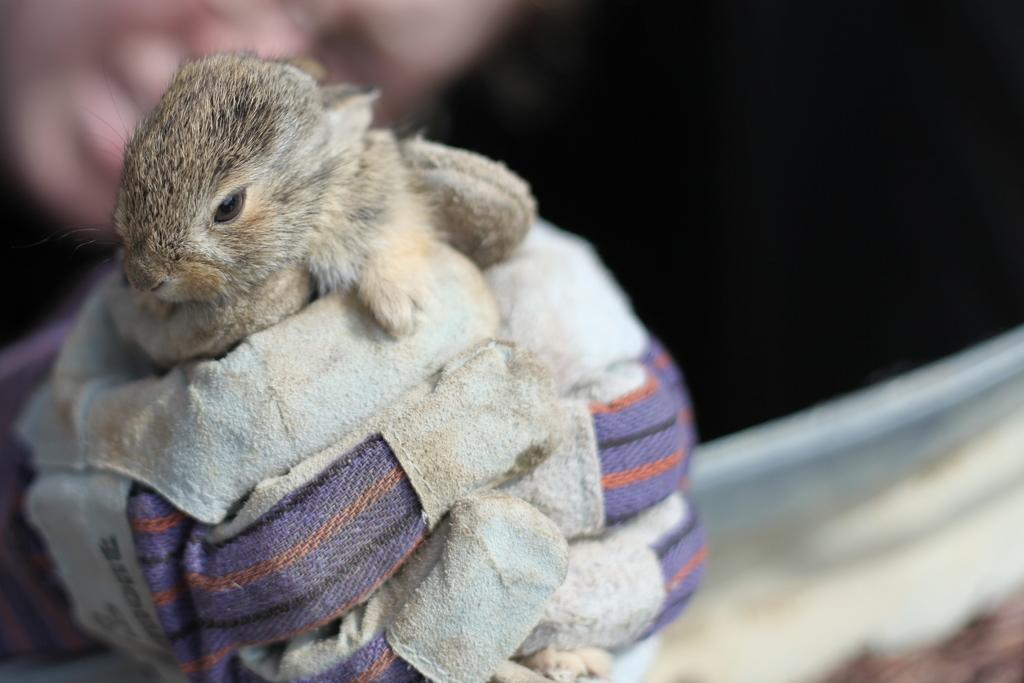Describe this image in one or two sentences. This picture is consists of a ground squirrel on the left side of the image, in the hands. 